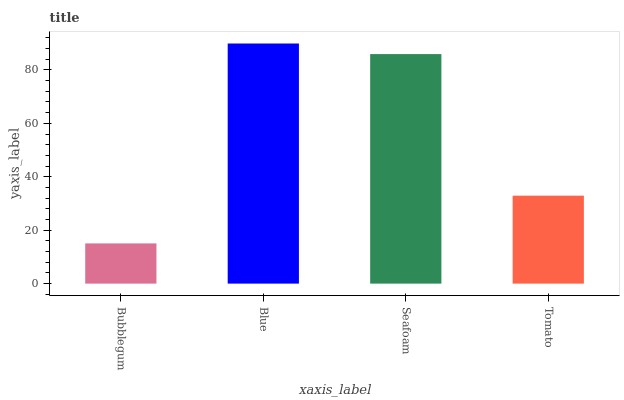Is Bubblegum the minimum?
Answer yes or no. Yes. Is Blue the maximum?
Answer yes or no. Yes. Is Seafoam the minimum?
Answer yes or no. No. Is Seafoam the maximum?
Answer yes or no. No. Is Blue greater than Seafoam?
Answer yes or no. Yes. Is Seafoam less than Blue?
Answer yes or no. Yes. Is Seafoam greater than Blue?
Answer yes or no. No. Is Blue less than Seafoam?
Answer yes or no. No. Is Seafoam the high median?
Answer yes or no. Yes. Is Tomato the low median?
Answer yes or no. Yes. Is Tomato the high median?
Answer yes or no. No. Is Blue the low median?
Answer yes or no. No. 